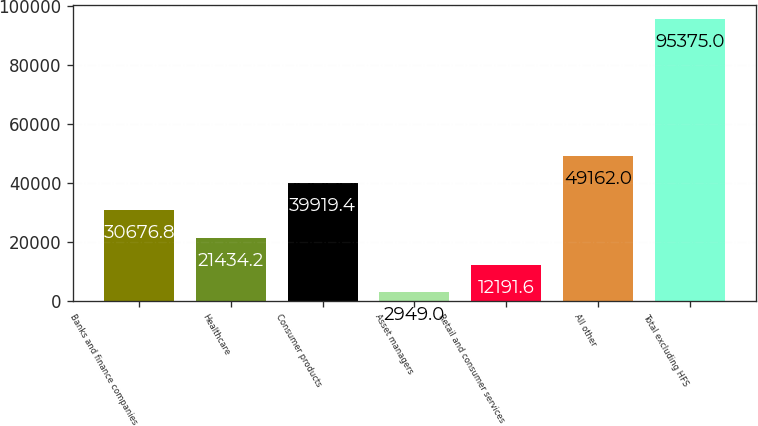<chart> <loc_0><loc_0><loc_500><loc_500><bar_chart><fcel>Banks and finance companies<fcel>Healthcare<fcel>Consumer products<fcel>Asset managers<fcel>Retail and consumer services<fcel>All other<fcel>Total excluding HFS<nl><fcel>30676.8<fcel>21434.2<fcel>39919.4<fcel>2949<fcel>12191.6<fcel>49162<fcel>95375<nl></chart> 